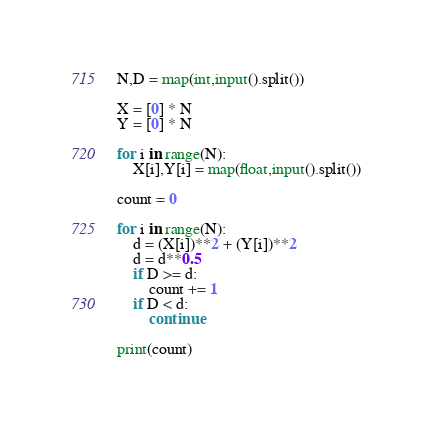<code> <loc_0><loc_0><loc_500><loc_500><_Python_>N,D = map(int,input().split())

X = [0] * N
Y = [0] * N

for i in range(N):
    X[i],Y[i] = map(float,input().split())

count = 0

for i in range(N):
    d = (X[i])**2 + (Y[i])**2
    d = d**0.5
    if D >= d:
        count += 1
    if D < d:
        continue
        
print(count)</code> 